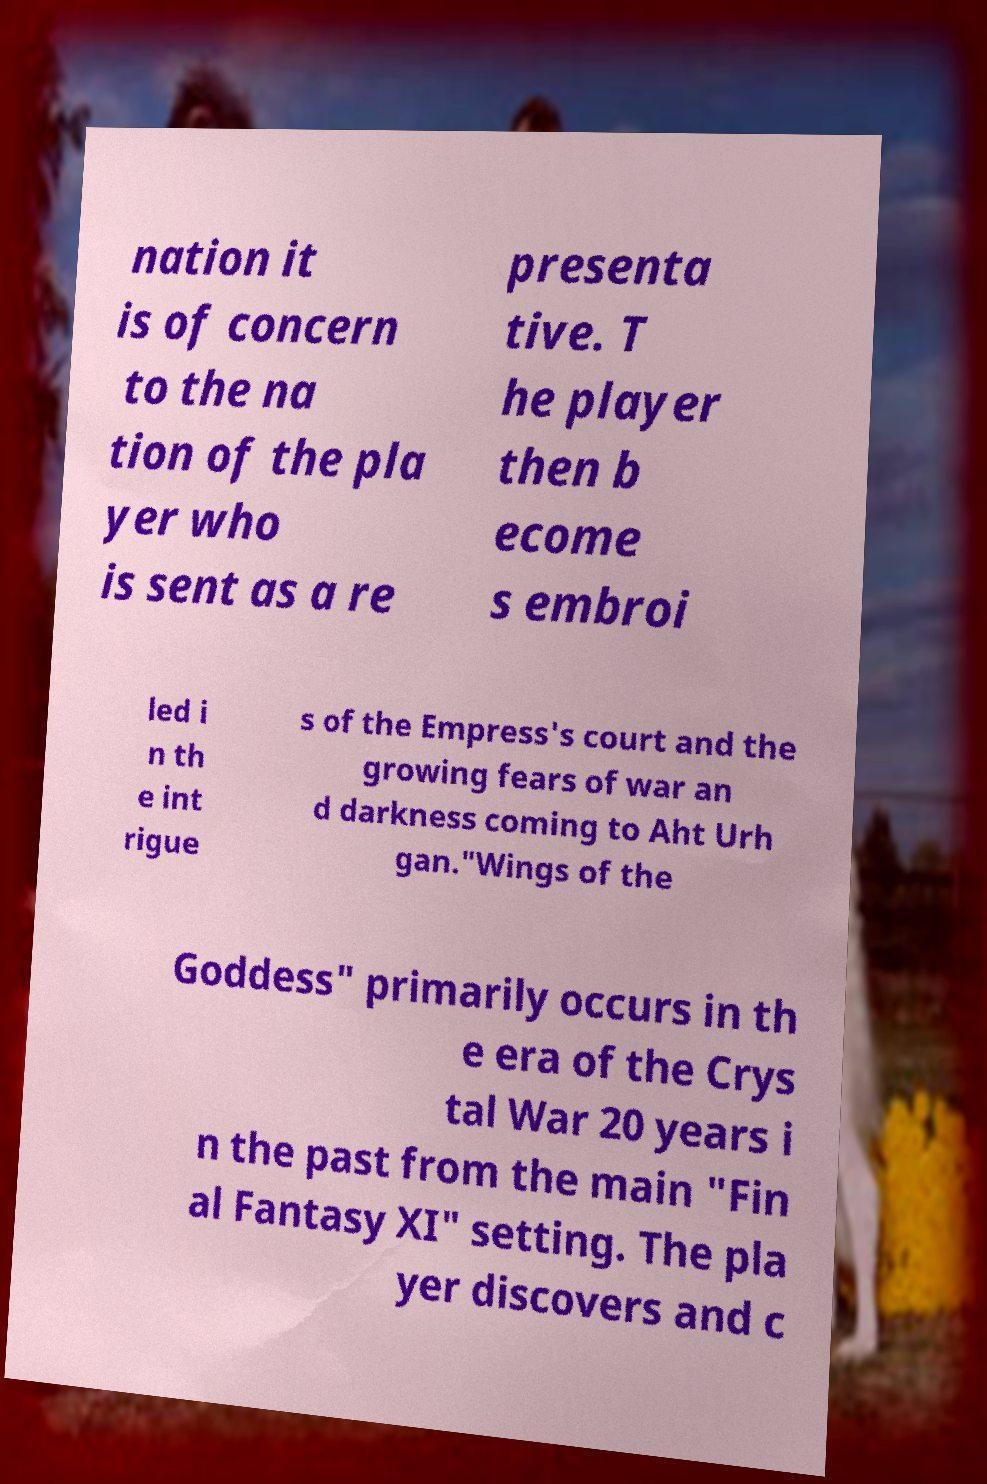Please read and relay the text visible in this image. What does it say? nation it is of concern to the na tion of the pla yer who is sent as a re presenta tive. T he player then b ecome s embroi led i n th e int rigue s of the Empress's court and the growing fears of war an d darkness coming to Aht Urh gan."Wings of the Goddess" primarily occurs in th e era of the Crys tal War 20 years i n the past from the main "Fin al Fantasy XI" setting. The pla yer discovers and c 